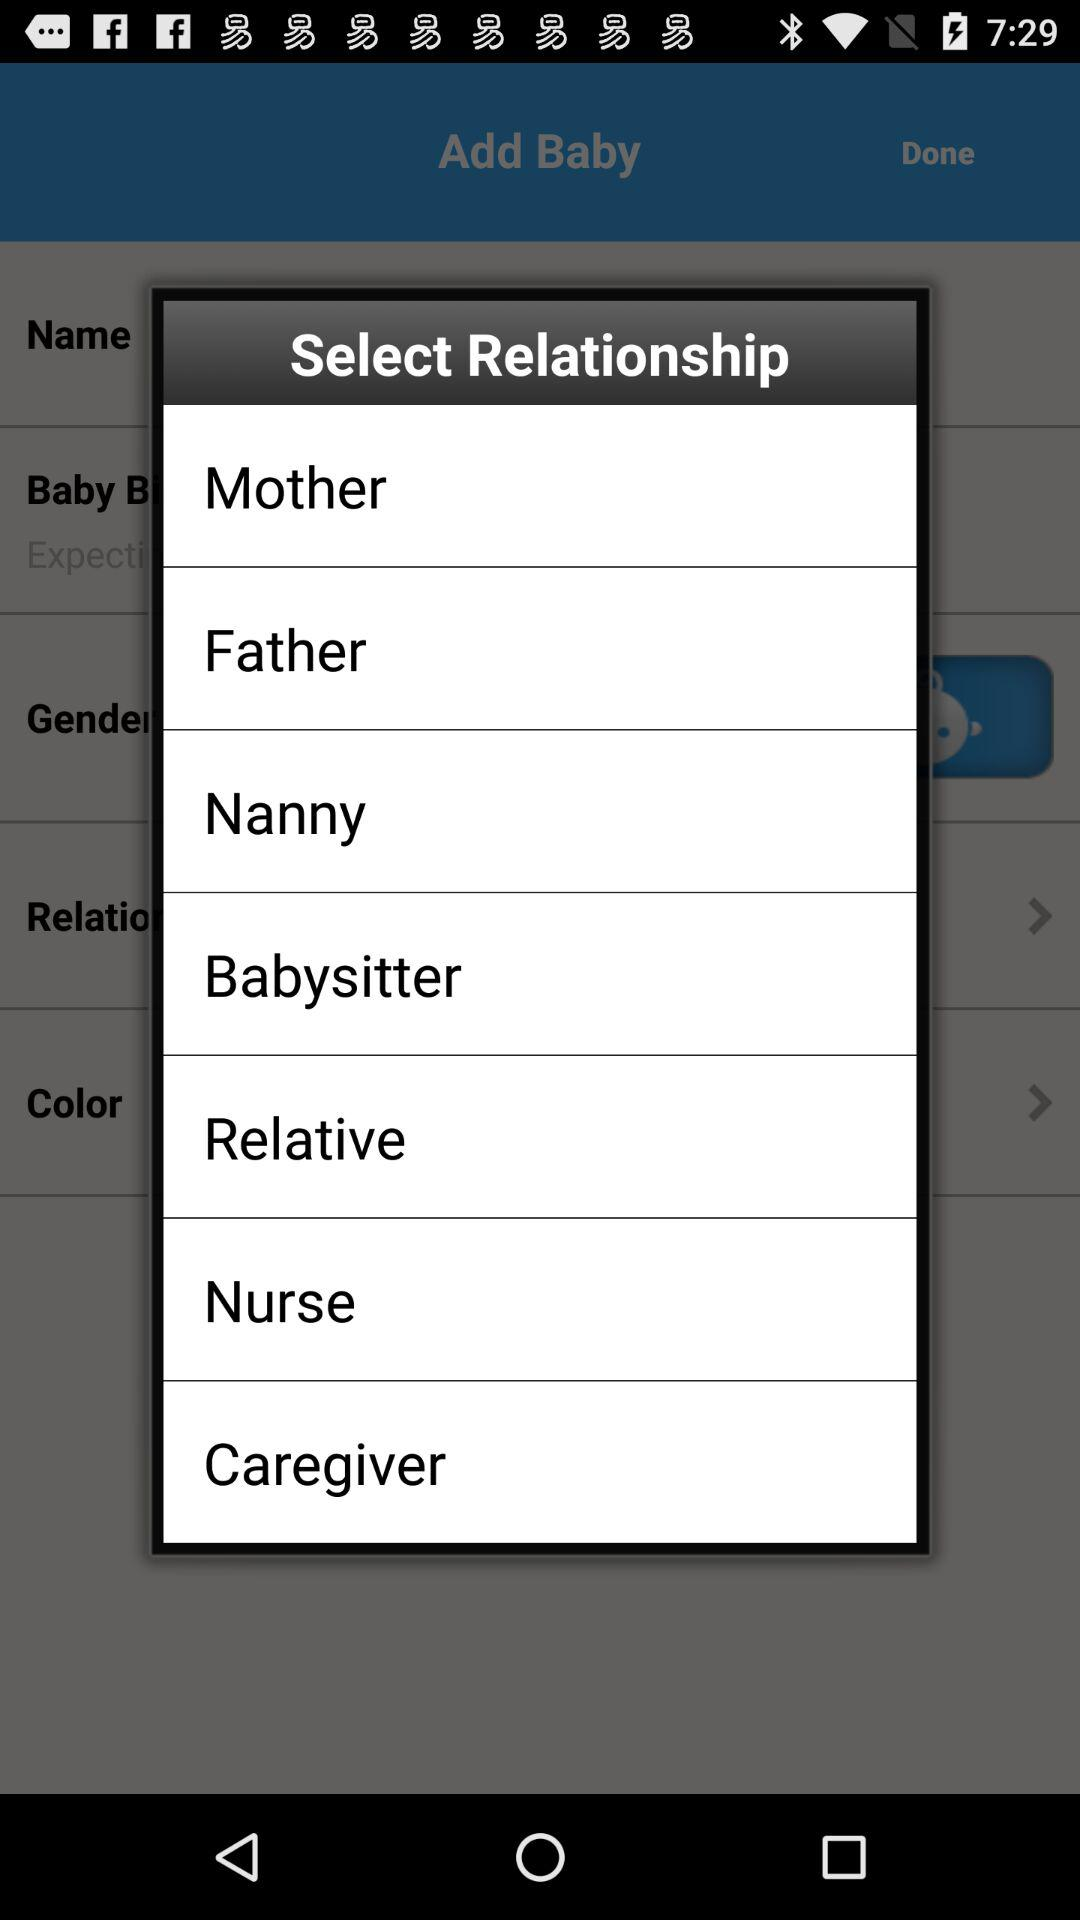How many relationship options are there in total?
Answer the question using a single word or phrase. 7 